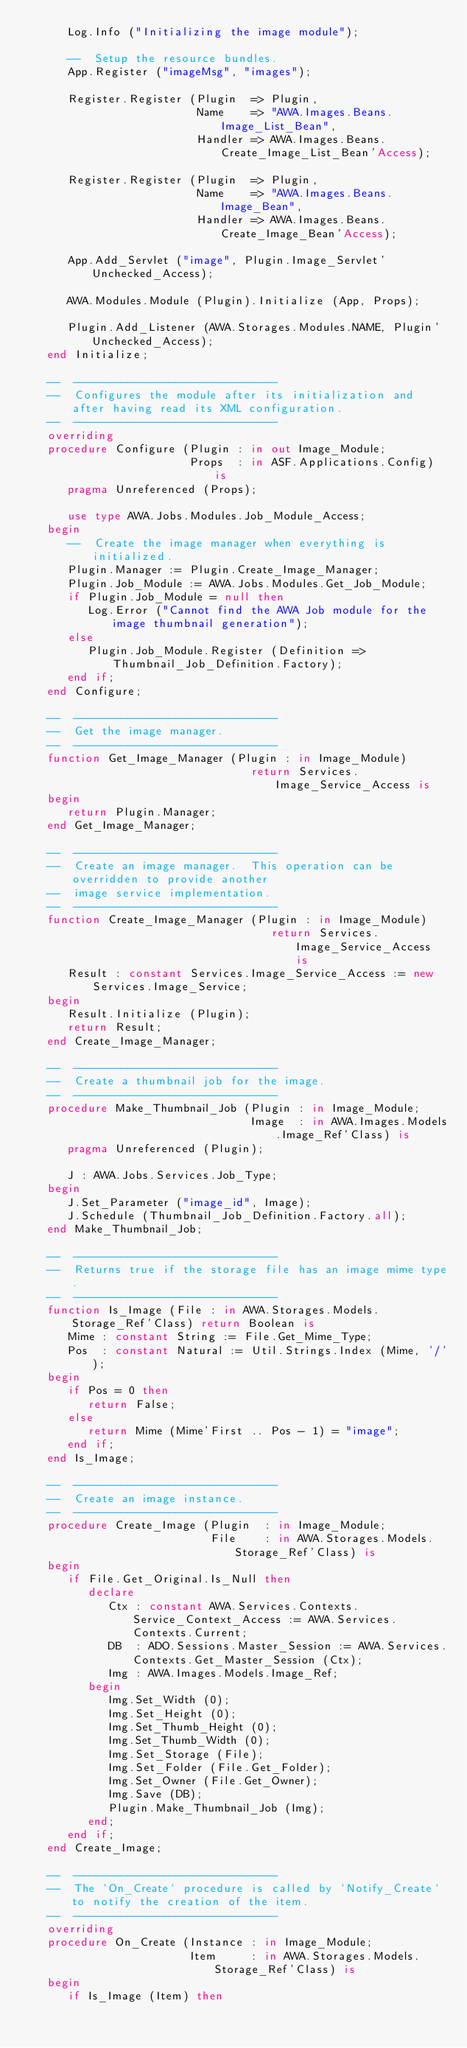<code> <loc_0><loc_0><loc_500><loc_500><_Ada_>      Log.Info ("Initializing the image module");

      --  Setup the resource bundles.
      App.Register ("imageMsg", "images");

      Register.Register (Plugin  => Plugin,
                         Name    => "AWA.Images.Beans.Image_List_Bean",
                         Handler => AWA.Images.Beans.Create_Image_List_Bean'Access);

      Register.Register (Plugin  => Plugin,
                         Name    => "AWA.Images.Beans.Image_Bean",
                         Handler => AWA.Images.Beans.Create_Image_Bean'Access);

      App.Add_Servlet ("image", Plugin.Image_Servlet'Unchecked_Access);

      AWA.Modules.Module (Plugin).Initialize (App, Props);

      Plugin.Add_Listener (AWA.Storages.Modules.NAME, Plugin'Unchecked_Access);
   end Initialize;

   --  ------------------------------
   --  Configures the module after its initialization and after having read its XML configuration.
   --  ------------------------------
   overriding
   procedure Configure (Plugin : in out Image_Module;
                        Props  : in ASF.Applications.Config) is
      pragma Unreferenced (Props);

      use type AWA.Jobs.Modules.Job_Module_Access;
   begin
      --  Create the image manager when everything is initialized.
      Plugin.Manager := Plugin.Create_Image_Manager;
      Plugin.Job_Module := AWA.Jobs.Modules.Get_Job_Module;
      if Plugin.Job_Module = null then
         Log.Error ("Cannot find the AWA Job module for the image thumbnail generation");
      else
         Plugin.Job_Module.Register (Definition => Thumbnail_Job_Definition.Factory);
      end if;
   end Configure;

   --  ------------------------------
   --  Get the image manager.
   --  ------------------------------
   function Get_Image_Manager (Plugin : in Image_Module)
                                 return Services.Image_Service_Access is
   begin
      return Plugin.Manager;
   end Get_Image_Manager;

   --  ------------------------------
   --  Create an image manager.  This operation can be overridden to provide another
   --  image service implementation.
   --  ------------------------------
   function Create_Image_Manager (Plugin : in Image_Module)
                                    return Services.Image_Service_Access is
      Result : constant Services.Image_Service_Access := new Services.Image_Service;
   begin
      Result.Initialize (Plugin);
      return Result;
   end Create_Image_Manager;

   --  ------------------------------
   --  Create a thumbnail job for the image.
   --  ------------------------------
   procedure Make_Thumbnail_Job (Plugin : in Image_Module;
                                 Image  : in AWA.Images.Models.Image_Ref'Class) is
      pragma Unreferenced (Plugin);

      J : AWA.Jobs.Services.Job_Type;
   begin
      J.Set_Parameter ("image_id", Image);
      J.Schedule (Thumbnail_Job_Definition.Factory.all);
   end Make_Thumbnail_Job;

   --  ------------------------------
   --  Returns true if the storage file has an image mime type.
   --  ------------------------------
   function Is_Image (File : in AWA.Storages.Models.Storage_Ref'Class) return Boolean is
      Mime : constant String := File.Get_Mime_Type;
      Pos  : constant Natural := Util.Strings.Index (Mime, '/');
   begin
      if Pos = 0 then
         return False;
      else
         return Mime (Mime'First .. Pos - 1) = "image";
      end if;
   end Is_Image;

   --  ------------------------------
   --  Create an image instance.
   --  ------------------------------
   procedure Create_Image (Plugin  : in Image_Module;
                           File    : in AWA.Storages.Models.Storage_Ref'Class) is
   begin
      if File.Get_Original.Is_Null then
         declare
            Ctx : constant AWA.Services.Contexts.Service_Context_Access := AWA.Services.Contexts.Current;
            DB  : ADO.Sessions.Master_Session := AWA.Services.Contexts.Get_Master_Session (Ctx);
            Img : AWA.Images.Models.Image_Ref;
         begin
            Img.Set_Width (0);
            Img.Set_Height (0);
            Img.Set_Thumb_Height (0);
            Img.Set_Thumb_Width (0);
            Img.Set_Storage (File);
            Img.Set_Folder (File.Get_Folder);
            Img.Set_Owner (File.Get_Owner);
            Img.Save (DB);
            Plugin.Make_Thumbnail_Job (Img);
         end;
      end if;
   end Create_Image;

   --  ------------------------------
   --  The `On_Create` procedure is called by `Notify_Create` to notify the creation of the item.
   --  ------------------------------
   overriding
   procedure On_Create (Instance : in Image_Module;
                        Item     : in AWA.Storages.Models.Storage_Ref'Class) is
   begin
      if Is_Image (Item) then</code> 